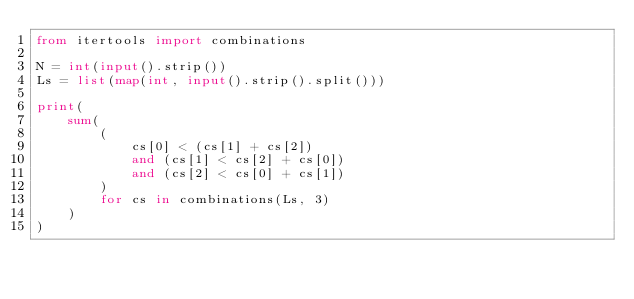<code> <loc_0><loc_0><loc_500><loc_500><_Python_>from itertools import combinations

N = int(input().strip())
Ls = list(map(int, input().strip().split()))

print(
    sum(
        (
            cs[0] < (cs[1] + cs[2])
            and (cs[1] < cs[2] + cs[0])
            and (cs[2] < cs[0] + cs[1])
        )
        for cs in combinations(Ls, 3)
    )
)</code> 